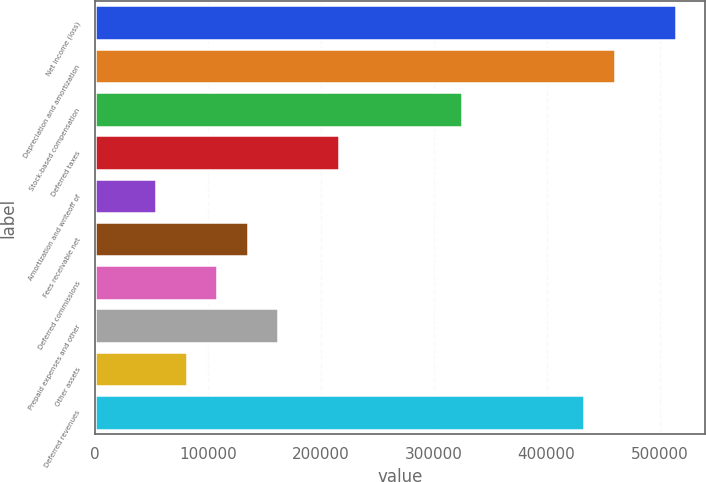Convert chart. <chart><loc_0><loc_0><loc_500><loc_500><bar_chart><fcel>Net income (loss)<fcel>Depreciation and amortization<fcel>Stock-based compensation<fcel>Deferred taxes<fcel>Amortization and writeoff of<fcel>Fees receivable net<fcel>Deferred commissions<fcel>Prepaid expenses and other<fcel>Other assets<fcel>Deferred revenues<nl><fcel>514297<fcel>460165<fcel>324836<fcel>216572<fcel>54176.8<fcel>135374<fcel>108309<fcel>162440<fcel>81242.7<fcel>433099<nl></chart> 